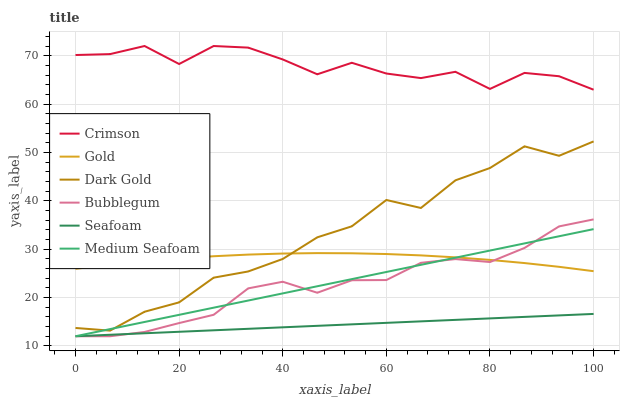Does Seafoam have the minimum area under the curve?
Answer yes or no. Yes. Does Crimson have the maximum area under the curve?
Answer yes or no. Yes. Does Dark Gold have the minimum area under the curve?
Answer yes or no. No. Does Dark Gold have the maximum area under the curve?
Answer yes or no. No. Is Seafoam the smoothest?
Answer yes or no. Yes. Is Dark Gold the roughest?
Answer yes or no. Yes. Is Dark Gold the smoothest?
Answer yes or no. No. Is Seafoam the roughest?
Answer yes or no. No. Does Dark Gold have the lowest value?
Answer yes or no. No. Does Dark Gold have the highest value?
Answer yes or no. No. Is Gold less than Crimson?
Answer yes or no. Yes. Is Crimson greater than Bubblegum?
Answer yes or no. Yes. Does Gold intersect Crimson?
Answer yes or no. No. 